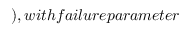<formula> <loc_0><loc_0><loc_500><loc_500>) , w i t h f a i l u r e p a r a m e t e r</formula> 